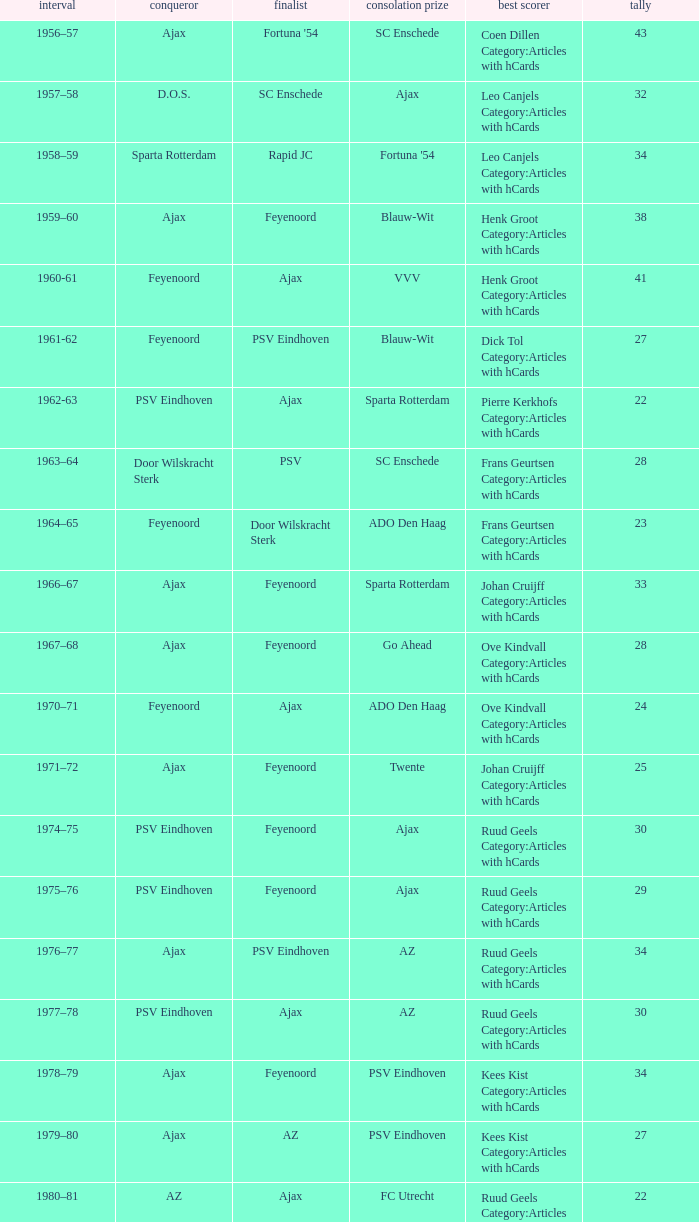When nac breda came in third place and psv eindhoven was the winner who is the top scorer? Klaas-Jan Huntelaar Category:Articles with hCards. 